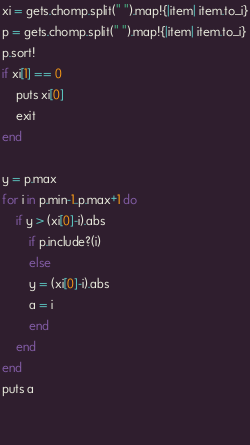Convert code to text. <code><loc_0><loc_0><loc_500><loc_500><_Ruby_>xi = gets.chomp.split(" ").map!{|item| item.to_i}
p = gets.chomp.split(" ").map!{|item| item.to_i}
p.sort!
if xi[1] == 0
    puts xi[0]
    exit
end

y = p.max
for i in p.min-1..p.max+1 do
    if y > (xi[0]-i).abs
        if p.include?(i)
        else
        y = (xi[0]-i).abs
        a = i
        end
    end
end
puts a

    
</code> 